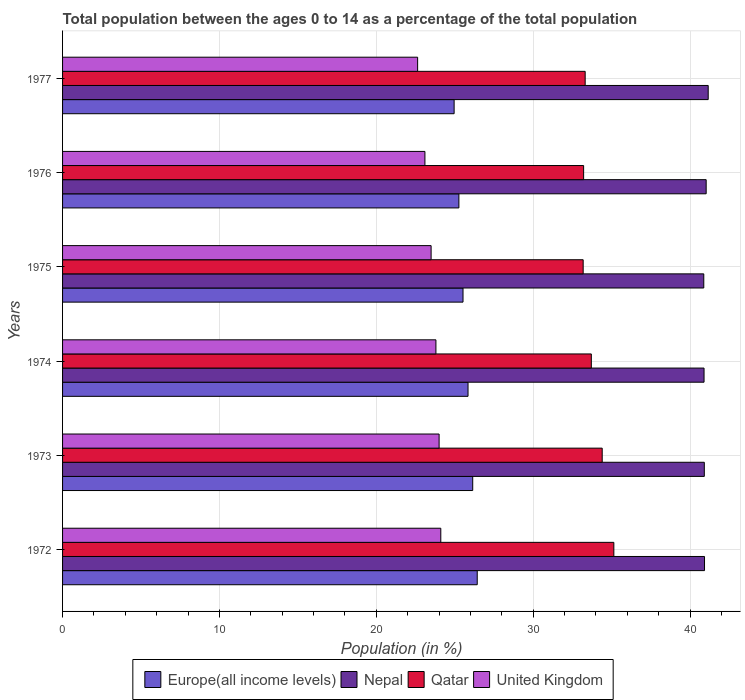How many different coloured bars are there?
Your answer should be very brief. 4. Are the number of bars per tick equal to the number of legend labels?
Your answer should be very brief. Yes. What is the label of the 4th group of bars from the top?
Your response must be concise. 1974. In how many cases, is the number of bars for a given year not equal to the number of legend labels?
Your response must be concise. 0. What is the percentage of the population ages 0 to 14 in Nepal in 1972?
Your answer should be very brief. 40.92. Across all years, what is the maximum percentage of the population ages 0 to 14 in Qatar?
Your response must be concise. 35.14. Across all years, what is the minimum percentage of the population ages 0 to 14 in Qatar?
Provide a succinct answer. 33.18. In which year was the percentage of the population ages 0 to 14 in Qatar maximum?
Your response must be concise. 1972. In which year was the percentage of the population ages 0 to 14 in Nepal minimum?
Provide a short and direct response. 1975. What is the total percentage of the population ages 0 to 14 in Europe(all income levels) in the graph?
Give a very brief answer. 154.17. What is the difference between the percentage of the population ages 0 to 14 in Nepal in 1975 and that in 1977?
Your response must be concise. -0.28. What is the difference between the percentage of the population ages 0 to 14 in Qatar in 1977 and the percentage of the population ages 0 to 14 in Nepal in 1973?
Your answer should be very brief. -7.59. What is the average percentage of the population ages 0 to 14 in Europe(all income levels) per year?
Your answer should be very brief. 25.69. In the year 1974, what is the difference between the percentage of the population ages 0 to 14 in Qatar and percentage of the population ages 0 to 14 in United Kingdom?
Your answer should be very brief. 9.91. What is the ratio of the percentage of the population ages 0 to 14 in Qatar in 1972 to that in 1975?
Give a very brief answer. 1.06. What is the difference between the highest and the second highest percentage of the population ages 0 to 14 in Nepal?
Your answer should be compact. 0.13. What is the difference between the highest and the lowest percentage of the population ages 0 to 14 in Qatar?
Ensure brevity in your answer.  1.96. Is it the case that in every year, the sum of the percentage of the population ages 0 to 14 in Qatar and percentage of the population ages 0 to 14 in Europe(all income levels) is greater than the sum of percentage of the population ages 0 to 14 in United Kingdom and percentage of the population ages 0 to 14 in Nepal?
Offer a terse response. Yes. What does the 1st bar from the top in 1973 represents?
Provide a short and direct response. United Kingdom. What does the 4th bar from the bottom in 1977 represents?
Offer a very short reply. United Kingdom. Is it the case that in every year, the sum of the percentage of the population ages 0 to 14 in Europe(all income levels) and percentage of the population ages 0 to 14 in United Kingdom is greater than the percentage of the population ages 0 to 14 in Qatar?
Make the answer very short. Yes. How many years are there in the graph?
Your answer should be very brief. 6. What is the difference between two consecutive major ticks on the X-axis?
Make the answer very short. 10. Does the graph contain any zero values?
Ensure brevity in your answer.  No. Does the graph contain grids?
Keep it short and to the point. Yes. Where does the legend appear in the graph?
Your response must be concise. Bottom center. How many legend labels are there?
Provide a succinct answer. 4. What is the title of the graph?
Offer a very short reply. Total population between the ages 0 to 14 as a percentage of the total population. Does "St. Lucia" appear as one of the legend labels in the graph?
Offer a terse response. No. What is the label or title of the X-axis?
Offer a very short reply. Population (in %). What is the Population (in %) of Europe(all income levels) in 1972?
Your response must be concise. 26.43. What is the Population (in %) of Nepal in 1972?
Offer a terse response. 40.92. What is the Population (in %) of Qatar in 1972?
Your answer should be compact. 35.14. What is the Population (in %) in United Kingdom in 1972?
Your answer should be compact. 24.11. What is the Population (in %) in Europe(all income levels) in 1973?
Offer a terse response. 26.14. What is the Population (in %) in Nepal in 1973?
Make the answer very short. 40.91. What is the Population (in %) of Qatar in 1973?
Your answer should be compact. 34.4. What is the Population (in %) in United Kingdom in 1973?
Your answer should be compact. 24. What is the Population (in %) in Europe(all income levels) in 1974?
Your answer should be compact. 25.84. What is the Population (in %) in Nepal in 1974?
Offer a very short reply. 40.89. What is the Population (in %) in Qatar in 1974?
Keep it short and to the point. 33.7. What is the Population (in %) in United Kingdom in 1974?
Provide a succinct answer. 23.8. What is the Population (in %) in Europe(all income levels) in 1975?
Give a very brief answer. 25.53. What is the Population (in %) in Nepal in 1975?
Provide a short and direct response. 40.87. What is the Population (in %) in Qatar in 1975?
Offer a terse response. 33.18. What is the Population (in %) of United Kingdom in 1975?
Your answer should be compact. 23.49. What is the Population (in %) of Europe(all income levels) in 1976?
Provide a succinct answer. 25.26. What is the Population (in %) in Nepal in 1976?
Offer a very short reply. 41.02. What is the Population (in %) in Qatar in 1976?
Offer a very short reply. 33.21. What is the Population (in %) in United Kingdom in 1976?
Keep it short and to the point. 23.1. What is the Population (in %) in Europe(all income levels) in 1977?
Provide a succinct answer. 24.96. What is the Population (in %) in Nepal in 1977?
Your response must be concise. 41.15. What is the Population (in %) in Qatar in 1977?
Offer a very short reply. 33.31. What is the Population (in %) in United Kingdom in 1977?
Make the answer very short. 22.63. Across all years, what is the maximum Population (in %) of Europe(all income levels)?
Your answer should be compact. 26.43. Across all years, what is the maximum Population (in %) in Nepal?
Keep it short and to the point. 41.15. Across all years, what is the maximum Population (in %) in Qatar?
Your answer should be very brief. 35.14. Across all years, what is the maximum Population (in %) of United Kingdom?
Offer a very short reply. 24.11. Across all years, what is the minimum Population (in %) of Europe(all income levels)?
Keep it short and to the point. 24.96. Across all years, what is the minimum Population (in %) in Nepal?
Your response must be concise. 40.87. Across all years, what is the minimum Population (in %) of Qatar?
Your answer should be compact. 33.18. Across all years, what is the minimum Population (in %) of United Kingdom?
Offer a terse response. 22.63. What is the total Population (in %) in Europe(all income levels) in the graph?
Offer a terse response. 154.17. What is the total Population (in %) in Nepal in the graph?
Your answer should be very brief. 245.76. What is the total Population (in %) of Qatar in the graph?
Your response must be concise. 202.95. What is the total Population (in %) of United Kingdom in the graph?
Your answer should be very brief. 141.13. What is the difference between the Population (in %) in Europe(all income levels) in 1972 and that in 1973?
Keep it short and to the point. 0.29. What is the difference between the Population (in %) in Nepal in 1972 and that in 1973?
Provide a short and direct response. 0.01. What is the difference between the Population (in %) of Qatar in 1972 and that in 1973?
Make the answer very short. 0.74. What is the difference between the Population (in %) in United Kingdom in 1972 and that in 1973?
Make the answer very short. 0.11. What is the difference between the Population (in %) in Europe(all income levels) in 1972 and that in 1974?
Your answer should be very brief. 0.59. What is the difference between the Population (in %) in Nepal in 1972 and that in 1974?
Offer a very short reply. 0.03. What is the difference between the Population (in %) in Qatar in 1972 and that in 1974?
Keep it short and to the point. 1.44. What is the difference between the Population (in %) in United Kingdom in 1972 and that in 1974?
Your response must be concise. 0.31. What is the difference between the Population (in %) in Europe(all income levels) in 1972 and that in 1975?
Your answer should be compact. 0.91. What is the difference between the Population (in %) of Nepal in 1972 and that in 1975?
Offer a terse response. 0.05. What is the difference between the Population (in %) in Qatar in 1972 and that in 1975?
Your response must be concise. 1.96. What is the difference between the Population (in %) of United Kingdom in 1972 and that in 1975?
Keep it short and to the point. 0.62. What is the difference between the Population (in %) of Europe(all income levels) in 1972 and that in 1976?
Give a very brief answer. 1.17. What is the difference between the Population (in %) of Nepal in 1972 and that in 1976?
Your answer should be very brief. -0.1. What is the difference between the Population (in %) in Qatar in 1972 and that in 1976?
Your response must be concise. 1.93. What is the difference between the Population (in %) in United Kingdom in 1972 and that in 1976?
Provide a succinct answer. 1.01. What is the difference between the Population (in %) of Europe(all income levels) in 1972 and that in 1977?
Your answer should be compact. 1.47. What is the difference between the Population (in %) in Nepal in 1972 and that in 1977?
Ensure brevity in your answer.  -0.24. What is the difference between the Population (in %) in Qatar in 1972 and that in 1977?
Make the answer very short. 1.83. What is the difference between the Population (in %) in United Kingdom in 1972 and that in 1977?
Ensure brevity in your answer.  1.48. What is the difference between the Population (in %) in Europe(all income levels) in 1973 and that in 1974?
Offer a very short reply. 0.3. What is the difference between the Population (in %) of Nepal in 1973 and that in 1974?
Give a very brief answer. 0.02. What is the difference between the Population (in %) in Qatar in 1973 and that in 1974?
Your answer should be compact. 0.69. What is the difference between the Population (in %) of United Kingdom in 1973 and that in 1974?
Offer a terse response. 0.2. What is the difference between the Population (in %) in Europe(all income levels) in 1973 and that in 1975?
Provide a short and direct response. 0.62. What is the difference between the Population (in %) in Nepal in 1973 and that in 1975?
Make the answer very short. 0.03. What is the difference between the Population (in %) in Qatar in 1973 and that in 1975?
Your response must be concise. 1.21. What is the difference between the Population (in %) in United Kingdom in 1973 and that in 1975?
Your response must be concise. 0.51. What is the difference between the Population (in %) of Europe(all income levels) in 1973 and that in 1976?
Give a very brief answer. 0.88. What is the difference between the Population (in %) in Nepal in 1973 and that in 1976?
Keep it short and to the point. -0.12. What is the difference between the Population (in %) of Qatar in 1973 and that in 1976?
Your answer should be compact. 1.18. What is the difference between the Population (in %) in United Kingdom in 1973 and that in 1976?
Your answer should be compact. 0.9. What is the difference between the Population (in %) in Europe(all income levels) in 1973 and that in 1977?
Provide a succinct answer. 1.19. What is the difference between the Population (in %) in Nepal in 1973 and that in 1977?
Offer a terse response. -0.25. What is the difference between the Population (in %) of Qatar in 1973 and that in 1977?
Your answer should be very brief. 1.09. What is the difference between the Population (in %) of United Kingdom in 1973 and that in 1977?
Your answer should be compact. 1.37. What is the difference between the Population (in %) in Europe(all income levels) in 1974 and that in 1975?
Your answer should be very brief. 0.32. What is the difference between the Population (in %) of Nepal in 1974 and that in 1975?
Offer a terse response. 0.02. What is the difference between the Population (in %) of Qatar in 1974 and that in 1975?
Give a very brief answer. 0.52. What is the difference between the Population (in %) of United Kingdom in 1974 and that in 1975?
Keep it short and to the point. 0.31. What is the difference between the Population (in %) of Europe(all income levels) in 1974 and that in 1976?
Provide a short and direct response. 0.58. What is the difference between the Population (in %) of Nepal in 1974 and that in 1976?
Your answer should be very brief. -0.13. What is the difference between the Population (in %) of Qatar in 1974 and that in 1976?
Give a very brief answer. 0.49. What is the difference between the Population (in %) of United Kingdom in 1974 and that in 1976?
Provide a succinct answer. 0.7. What is the difference between the Population (in %) of Europe(all income levels) in 1974 and that in 1977?
Offer a terse response. 0.89. What is the difference between the Population (in %) in Nepal in 1974 and that in 1977?
Offer a very short reply. -0.27. What is the difference between the Population (in %) in Qatar in 1974 and that in 1977?
Provide a succinct answer. 0.39. What is the difference between the Population (in %) in United Kingdom in 1974 and that in 1977?
Give a very brief answer. 1.17. What is the difference between the Population (in %) of Europe(all income levels) in 1975 and that in 1976?
Your response must be concise. 0.26. What is the difference between the Population (in %) in Nepal in 1975 and that in 1976?
Keep it short and to the point. -0.15. What is the difference between the Population (in %) of Qatar in 1975 and that in 1976?
Your answer should be very brief. -0.03. What is the difference between the Population (in %) of United Kingdom in 1975 and that in 1976?
Provide a short and direct response. 0.39. What is the difference between the Population (in %) in Europe(all income levels) in 1975 and that in 1977?
Your answer should be very brief. 0.57. What is the difference between the Population (in %) of Nepal in 1975 and that in 1977?
Your answer should be very brief. -0.28. What is the difference between the Population (in %) of Qatar in 1975 and that in 1977?
Provide a short and direct response. -0.13. What is the difference between the Population (in %) of United Kingdom in 1975 and that in 1977?
Offer a very short reply. 0.86. What is the difference between the Population (in %) of Europe(all income levels) in 1976 and that in 1977?
Make the answer very short. 0.3. What is the difference between the Population (in %) of Nepal in 1976 and that in 1977?
Provide a short and direct response. -0.13. What is the difference between the Population (in %) of Qatar in 1976 and that in 1977?
Your answer should be compact. -0.1. What is the difference between the Population (in %) in United Kingdom in 1976 and that in 1977?
Make the answer very short. 0.47. What is the difference between the Population (in %) of Europe(all income levels) in 1972 and the Population (in %) of Nepal in 1973?
Your answer should be compact. -14.47. What is the difference between the Population (in %) of Europe(all income levels) in 1972 and the Population (in %) of Qatar in 1973?
Provide a succinct answer. -7.97. What is the difference between the Population (in %) of Europe(all income levels) in 1972 and the Population (in %) of United Kingdom in 1973?
Offer a very short reply. 2.43. What is the difference between the Population (in %) in Nepal in 1972 and the Population (in %) in Qatar in 1973?
Give a very brief answer. 6.52. What is the difference between the Population (in %) in Nepal in 1972 and the Population (in %) in United Kingdom in 1973?
Provide a short and direct response. 16.92. What is the difference between the Population (in %) of Qatar in 1972 and the Population (in %) of United Kingdom in 1973?
Your answer should be very brief. 11.14. What is the difference between the Population (in %) in Europe(all income levels) in 1972 and the Population (in %) in Nepal in 1974?
Keep it short and to the point. -14.46. What is the difference between the Population (in %) of Europe(all income levels) in 1972 and the Population (in %) of Qatar in 1974?
Ensure brevity in your answer.  -7.27. What is the difference between the Population (in %) of Europe(all income levels) in 1972 and the Population (in %) of United Kingdom in 1974?
Offer a very short reply. 2.63. What is the difference between the Population (in %) in Nepal in 1972 and the Population (in %) in Qatar in 1974?
Your response must be concise. 7.21. What is the difference between the Population (in %) of Nepal in 1972 and the Population (in %) of United Kingdom in 1974?
Provide a succinct answer. 17.12. What is the difference between the Population (in %) in Qatar in 1972 and the Population (in %) in United Kingdom in 1974?
Your response must be concise. 11.34. What is the difference between the Population (in %) of Europe(all income levels) in 1972 and the Population (in %) of Nepal in 1975?
Offer a very short reply. -14.44. What is the difference between the Population (in %) of Europe(all income levels) in 1972 and the Population (in %) of Qatar in 1975?
Keep it short and to the point. -6.75. What is the difference between the Population (in %) in Europe(all income levels) in 1972 and the Population (in %) in United Kingdom in 1975?
Offer a very short reply. 2.94. What is the difference between the Population (in %) of Nepal in 1972 and the Population (in %) of Qatar in 1975?
Your answer should be compact. 7.74. What is the difference between the Population (in %) in Nepal in 1972 and the Population (in %) in United Kingdom in 1975?
Ensure brevity in your answer.  17.43. What is the difference between the Population (in %) of Qatar in 1972 and the Population (in %) of United Kingdom in 1975?
Keep it short and to the point. 11.65. What is the difference between the Population (in %) of Europe(all income levels) in 1972 and the Population (in %) of Nepal in 1976?
Give a very brief answer. -14.59. What is the difference between the Population (in %) of Europe(all income levels) in 1972 and the Population (in %) of Qatar in 1976?
Your answer should be compact. -6.78. What is the difference between the Population (in %) of Europe(all income levels) in 1972 and the Population (in %) of United Kingdom in 1976?
Ensure brevity in your answer.  3.33. What is the difference between the Population (in %) of Nepal in 1972 and the Population (in %) of Qatar in 1976?
Provide a short and direct response. 7.71. What is the difference between the Population (in %) in Nepal in 1972 and the Population (in %) in United Kingdom in 1976?
Your response must be concise. 17.82. What is the difference between the Population (in %) of Qatar in 1972 and the Population (in %) of United Kingdom in 1976?
Provide a succinct answer. 12.04. What is the difference between the Population (in %) in Europe(all income levels) in 1972 and the Population (in %) in Nepal in 1977?
Make the answer very short. -14.72. What is the difference between the Population (in %) of Europe(all income levels) in 1972 and the Population (in %) of Qatar in 1977?
Provide a succinct answer. -6.88. What is the difference between the Population (in %) in Europe(all income levels) in 1972 and the Population (in %) in United Kingdom in 1977?
Offer a very short reply. 3.8. What is the difference between the Population (in %) of Nepal in 1972 and the Population (in %) of Qatar in 1977?
Offer a terse response. 7.61. What is the difference between the Population (in %) in Nepal in 1972 and the Population (in %) in United Kingdom in 1977?
Offer a terse response. 18.29. What is the difference between the Population (in %) in Qatar in 1972 and the Population (in %) in United Kingdom in 1977?
Provide a succinct answer. 12.51. What is the difference between the Population (in %) of Europe(all income levels) in 1973 and the Population (in %) of Nepal in 1974?
Provide a succinct answer. -14.75. What is the difference between the Population (in %) in Europe(all income levels) in 1973 and the Population (in %) in Qatar in 1974?
Give a very brief answer. -7.56. What is the difference between the Population (in %) of Europe(all income levels) in 1973 and the Population (in %) of United Kingdom in 1974?
Ensure brevity in your answer.  2.35. What is the difference between the Population (in %) in Nepal in 1973 and the Population (in %) in Qatar in 1974?
Offer a very short reply. 7.2. What is the difference between the Population (in %) of Nepal in 1973 and the Population (in %) of United Kingdom in 1974?
Keep it short and to the point. 17.11. What is the difference between the Population (in %) in Qatar in 1973 and the Population (in %) in United Kingdom in 1974?
Provide a short and direct response. 10.6. What is the difference between the Population (in %) of Europe(all income levels) in 1973 and the Population (in %) of Nepal in 1975?
Keep it short and to the point. -14.73. What is the difference between the Population (in %) in Europe(all income levels) in 1973 and the Population (in %) in Qatar in 1975?
Make the answer very short. -7.04. What is the difference between the Population (in %) of Europe(all income levels) in 1973 and the Population (in %) of United Kingdom in 1975?
Ensure brevity in your answer.  2.65. What is the difference between the Population (in %) of Nepal in 1973 and the Population (in %) of Qatar in 1975?
Provide a short and direct response. 7.72. What is the difference between the Population (in %) in Nepal in 1973 and the Population (in %) in United Kingdom in 1975?
Provide a short and direct response. 17.41. What is the difference between the Population (in %) in Qatar in 1973 and the Population (in %) in United Kingdom in 1975?
Provide a short and direct response. 10.91. What is the difference between the Population (in %) in Europe(all income levels) in 1973 and the Population (in %) in Nepal in 1976?
Your answer should be compact. -14.88. What is the difference between the Population (in %) of Europe(all income levels) in 1973 and the Population (in %) of Qatar in 1976?
Your answer should be compact. -7.07. What is the difference between the Population (in %) in Europe(all income levels) in 1973 and the Population (in %) in United Kingdom in 1976?
Offer a terse response. 3.05. What is the difference between the Population (in %) in Nepal in 1973 and the Population (in %) in Qatar in 1976?
Keep it short and to the point. 7.69. What is the difference between the Population (in %) in Nepal in 1973 and the Population (in %) in United Kingdom in 1976?
Make the answer very short. 17.81. What is the difference between the Population (in %) in Qatar in 1973 and the Population (in %) in United Kingdom in 1976?
Your answer should be compact. 11.3. What is the difference between the Population (in %) in Europe(all income levels) in 1973 and the Population (in %) in Nepal in 1977?
Your answer should be compact. -15.01. What is the difference between the Population (in %) in Europe(all income levels) in 1973 and the Population (in %) in Qatar in 1977?
Provide a short and direct response. -7.17. What is the difference between the Population (in %) in Europe(all income levels) in 1973 and the Population (in %) in United Kingdom in 1977?
Your response must be concise. 3.51. What is the difference between the Population (in %) of Nepal in 1973 and the Population (in %) of Qatar in 1977?
Make the answer very short. 7.59. What is the difference between the Population (in %) in Nepal in 1973 and the Population (in %) in United Kingdom in 1977?
Your answer should be compact. 18.27. What is the difference between the Population (in %) of Qatar in 1973 and the Population (in %) of United Kingdom in 1977?
Give a very brief answer. 11.77. What is the difference between the Population (in %) of Europe(all income levels) in 1974 and the Population (in %) of Nepal in 1975?
Keep it short and to the point. -15.03. What is the difference between the Population (in %) of Europe(all income levels) in 1974 and the Population (in %) of Qatar in 1975?
Your response must be concise. -7.34. What is the difference between the Population (in %) in Europe(all income levels) in 1974 and the Population (in %) in United Kingdom in 1975?
Your answer should be very brief. 2.35. What is the difference between the Population (in %) in Nepal in 1974 and the Population (in %) in Qatar in 1975?
Provide a short and direct response. 7.71. What is the difference between the Population (in %) of Nepal in 1974 and the Population (in %) of United Kingdom in 1975?
Provide a succinct answer. 17.4. What is the difference between the Population (in %) in Qatar in 1974 and the Population (in %) in United Kingdom in 1975?
Ensure brevity in your answer.  10.21. What is the difference between the Population (in %) of Europe(all income levels) in 1974 and the Population (in %) of Nepal in 1976?
Give a very brief answer. -15.18. What is the difference between the Population (in %) of Europe(all income levels) in 1974 and the Population (in %) of Qatar in 1976?
Keep it short and to the point. -7.37. What is the difference between the Population (in %) in Europe(all income levels) in 1974 and the Population (in %) in United Kingdom in 1976?
Offer a very short reply. 2.75. What is the difference between the Population (in %) of Nepal in 1974 and the Population (in %) of Qatar in 1976?
Provide a succinct answer. 7.68. What is the difference between the Population (in %) in Nepal in 1974 and the Population (in %) in United Kingdom in 1976?
Offer a very short reply. 17.79. What is the difference between the Population (in %) of Qatar in 1974 and the Population (in %) of United Kingdom in 1976?
Provide a short and direct response. 10.61. What is the difference between the Population (in %) of Europe(all income levels) in 1974 and the Population (in %) of Nepal in 1977?
Your response must be concise. -15.31. What is the difference between the Population (in %) of Europe(all income levels) in 1974 and the Population (in %) of Qatar in 1977?
Your answer should be compact. -7.47. What is the difference between the Population (in %) of Europe(all income levels) in 1974 and the Population (in %) of United Kingdom in 1977?
Provide a succinct answer. 3.21. What is the difference between the Population (in %) of Nepal in 1974 and the Population (in %) of Qatar in 1977?
Provide a short and direct response. 7.58. What is the difference between the Population (in %) of Nepal in 1974 and the Population (in %) of United Kingdom in 1977?
Give a very brief answer. 18.26. What is the difference between the Population (in %) of Qatar in 1974 and the Population (in %) of United Kingdom in 1977?
Provide a succinct answer. 11.07. What is the difference between the Population (in %) in Europe(all income levels) in 1975 and the Population (in %) in Nepal in 1976?
Give a very brief answer. -15.5. What is the difference between the Population (in %) of Europe(all income levels) in 1975 and the Population (in %) of Qatar in 1976?
Provide a succinct answer. -7.69. What is the difference between the Population (in %) in Europe(all income levels) in 1975 and the Population (in %) in United Kingdom in 1976?
Give a very brief answer. 2.43. What is the difference between the Population (in %) in Nepal in 1975 and the Population (in %) in Qatar in 1976?
Ensure brevity in your answer.  7.66. What is the difference between the Population (in %) of Nepal in 1975 and the Population (in %) of United Kingdom in 1976?
Provide a succinct answer. 17.77. What is the difference between the Population (in %) of Qatar in 1975 and the Population (in %) of United Kingdom in 1976?
Provide a short and direct response. 10.09. What is the difference between the Population (in %) of Europe(all income levels) in 1975 and the Population (in %) of Nepal in 1977?
Offer a terse response. -15.63. What is the difference between the Population (in %) in Europe(all income levels) in 1975 and the Population (in %) in Qatar in 1977?
Offer a very short reply. -7.79. What is the difference between the Population (in %) of Europe(all income levels) in 1975 and the Population (in %) of United Kingdom in 1977?
Provide a succinct answer. 2.89. What is the difference between the Population (in %) of Nepal in 1975 and the Population (in %) of Qatar in 1977?
Your answer should be very brief. 7.56. What is the difference between the Population (in %) of Nepal in 1975 and the Population (in %) of United Kingdom in 1977?
Offer a terse response. 18.24. What is the difference between the Population (in %) in Qatar in 1975 and the Population (in %) in United Kingdom in 1977?
Your answer should be very brief. 10.55. What is the difference between the Population (in %) in Europe(all income levels) in 1976 and the Population (in %) in Nepal in 1977?
Give a very brief answer. -15.89. What is the difference between the Population (in %) in Europe(all income levels) in 1976 and the Population (in %) in Qatar in 1977?
Your answer should be very brief. -8.05. What is the difference between the Population (in %) of Europe(all income levels) in 1976 and the Population (in %) of United Kingdom in 1977?
Your answer should be compact. 2.63. What is the difference between the Population (in %) in Nepal in 1976 and the Population (in %) in Qatar in 1977?
Provide a succinct answer. 7.71. What is the difference between the Population (in %) of Nepal in 1976 and the Population (in %) of United Kingdom in 1977?
Provide a short and direct response. 18.39. What is the difference between the Population (in %) in Qatar in 1976 and the Population (in %) in United Kingdom in 1977?
Provide a short and direct response. 10.58. What is the average Population (in %) in Europe(all income levels) per year?
Ensure brevity in your answer.  25.69. What is the average Population (in %) of Nepal per year?
Your response must be concise. 40.96. What is the average Population (in %) in Qatar per year?
Provide a short and direct response. 33.83. What is the average Population (in %) of United Kingdom per year?
Make the answer very short. 23.52. In the year 1972, what is the difference between the Population (in %) in Europe(all income levels) and Population (in %) in Nepal?
Provide a succinct answer. -14.49. In the year 1972, what is the difference between the Population (in %) in Europe(all income levels) and Population (in %) in Qatar?
Your answer should be compact. -8.71. In the year 1972, what is the difference between the Population (in %) in Europe(all income levels) and Population (in %) in United Kingdom?
Provide a succinct answer. 2.32. In the year 1972, what is the difference between the Population (in %) of Nepal and Population (in %) of Qatar?
Provide a short and direct response. 5.78. In the year 1972, what is the difference between the Population (in %) in Nepal and Population (in %) in United Kingdom?
Ensure brevity in your answer.  16.81. In the year 1972, what is the difference between the Population (in %) of Qatar and Population (in %) of United Kingdom?
Your answer should be very brief. 11.03. In the year 1973, what is the difference between the Population (in %) in Europe(all income levels) and Population (in %) in Nepal?
Your answer should be compact. -14.76. In the year 1973, what is the difference between the Population (in %) in Europe(all income levels) and Population (in %) in Qatar?
Keep it short and to the point. -8.25. In the year 1973, what is the difference between the Population (in %) of Europe(all income levels) and Population (in %) of United Kingdom?
Provide a succinct answer. 2.14. In the year 1973, what is the difference between the Population (in %) in Nepal and Population (in %) in Qatar?
Keep it short and to the point. 6.51. In the year 1973, what is the difference between the Population (in %) in Nepal and Population (in %) in United Kingdom?
Provide a succinct answer. 16.9. In the year 1973, what is the difference between the Population (in %) in Qatar and Population (in %) in United Kingdom?
Offer a very short reply. 10.4. In the year 1974, what is the difference between the Population (in %) of Europe(all income levels) and Population (in %) of Nepal?
Give a very brief answer. -15.04. In the year 1974, what is the difference between the Population (in %) of Europe(all income levels) and Population (in %) of Qatar?
Keep it short and to the point. -7.86. In the year 1974, what is the difference between the Population (in %) in Europe(all income levels) and Population (in %) in United Kingdom?
Provide a succinct answer. 2.05. In the year 1974, what is the difference between the Population (in %) of Nepal and Population (in %) of Qatar?
Your response must be concise. 7.18. In the year 1974, what is the difference between the Population (in %) of Nepal and Population (in %) of United Kingdom?
Your answer should be very brief. 17.09. In the year 1974, what is the difference between the Population (in %) of Qatar and Population (in %) of United Kingdom?
Your answer should be very brief. 9.91. In the year 1975, what is the difference between the Population (in %) in Europe(all income levels) and Population (in %) in Nepal?
Your answer should be compact. -15.35. In the year 1975, what is the difference between the Population (in %) in Europe(all income levels) and Population (in %) in Qatar?
Provide a short and direct response. -7.66. In the year 1975, what is the difference between the Population (in %) in Europe(all income levels) and Population (in %) in United Kingdom?
Keep it short and to the point. 2.03. In the year 1975, what is the difference between the Population (in %) of Nepal and Population (in %) of Qatar?
Ensure brevity in your answer.  7.69. In the year 1975, what is the difference between the Population (in %) in Nepal and Population (in %) in United Kingdom?
Give a very brief answer. 17.38. In the year 1975, what is the difference between the Population (in %) in Qatar and Population (in %) in United Kingdom?
Give a very brief answer. 9.69. In the year 1976, what is the difference between the Population (in %) of Europe(all income levels) and Population (in %) of Nepal?
Provide a short and direct response. -15.76. In the year 1976, what is the difference between the Population (in %) of Europe(all income levels) and Population (in %) of Qatar?
Provide a succinct answer. -7.95. In the year 1976, what is the difference between the Population (in %) in Europe(all income levels) and Population (in %) in United Kingdom?
Your answer should be very brief. 2.17. In the year 1976, what is the difference between the Population (in %) in Nepal and Population (in %) in Qatar?
Make the answer very short. 7.81. In the year 1976, what is the difference between the Population (in %) in Nepal and Population (in %) in United Kingdom?
Give a very brief answer. 17.93. In the year 1976, what is the difference between the Population (in %) of Qatar and Population (in %) of United Kingdom?
Offer a terse response. 10.12. In the year 1977, what is the difference between the Population (in %) in Europe(all income levels) and Population (in %) in Nepal?
Your answer should be compact. -16.2. In the year 1977, what is the difference between the Population (in %) in Europe(all income levels) and Population (in %) in Qatar?
Your response must be concise. -8.35. In the year 1977, what is the difference between the Population (in %) of Europe(all income levels) and Population (in %) of United Kingdom?
Your answer should be compact. 2.33. In the year 1977, what is the difference between the Population (in %) in Nepal and Population (in %) in Qatar?
Keep it short and to the point. 7.84. In the year 1977, what is the difference between the Population (in %) of Nepal and Population (in %) of United Kingdom?
Provide a short and direct response. 18.52. In the year 1977, what is the difference between the Population (in %) of Qatar and Population (in %) of United Kingdom?
Offer a very short reply. 10.68. What is the ratio of the Population (in %) in Nepal in 1972 to that in 1973?
Offer a terse response. 1. What is the ratio of the Population (in %) of Qatar in 1972 to that in 1973?
Provide a short and direct response. 1.02. What is the ratio of the Population (in %) of Europe(all income levels) in 1972 to that in 1974?
Provide a succinct answer. 1.02. What is the ratio of the Population (in %) of Qatar in 1972 to that in 1974?
Give a very brief answer. 1.04. What is the ratio of the Population (in %) in United Kingdom in 1972 to that in 1974?
Ensure brevity in your answer.  1.01. What is the ratio of the Population (in %) of Europe(all income levels) in 1972 to that in 1975?
Offer a very short reply. 1.04. What is the ratio of the Population (in %) of Qatar in 1972 to that in 1975?
Ensure brevity in your answer.  1.06. What is the ratio of the Population (in %) in United Kingdom in 1972 to that in 1975?
Provide a succinct answer. 1.03. What is the ratio of the Population (in %) in Europe(all income levels) in 1972 to that in 1976?
Make the answer very short. 1.05. What is the ratio of the Population (in %) in Qatar in 1972 to that in 1976?
Your answer should be very brief. 1.06. What is the ratio of the Population (in %) in United Kingdom in 1972 to that in 1976?
Your answer should be compact. 1.04. What is the ratio of the Population (in %) of Europe(all income levels) in 1972 to that in 1977?
Give a very brief answer. 1.06. What is the ratio of the Population (in %) in Qatar in 1972 to that in 1977?
Make the answer very short. 1.05. What is the ratio of the Population (in %) in United Kingdom in 1972 to that in 1977?
Give a very brief answer. 1.07. What is the ratio of the Population (in %) of Europe(all income levels) in 1973 to that in 1974?
Your answer should be very brief. 1.01. What is the ratio of the Population (in %) of Qatar in 1973 to that in 1974?
Offer a very short reply. 1.02. What is the ratio of the Population (in %) in United Kingdom in 1973 to that in 1974?
Make the answer very short. 1.01. What is the ratio of the Population (in %) in Europe(all income levels) in 1973 to that in 1975?
Offer a terse response. 1.02. What is the ratio of the Population (in %) in Qatar in 1973 to that in 1975?
Offer a terse response. 1.04. What is the ratio of the Population (in %) in United Kingdom in 1973 to that in 1975?
Give a very brief answer. 1.02. What is the ratio of the Population (in %) in Europe(all income levels) in 1973 to that in 1976?
Offer a terse response. 1.03. What is the ratio of the Population (in %) of Nepal in 1973 to that in 1976?
Make the answer very short. 1. What is the ratio of the Population (in %) in Qatar in 1973 to that in 1976?
Keep it short and to the point. 1.04. What is the ratio of the Population (in %) in United Kingdom in 1973 to that in 1976?
Your answer should be compact. 1.04. What is the ratio of the Population (in %) of Europe(all income levels) in 1973 to that in 1977?
Your answer should be very brief. 1.05. What is the ratio of the Population (in %) in Nepal in 1973 to that in 1977?
Provide a succinct answer. 0.99. What is the ratio of the Population (in %) in Qatar in 1973 to that in 1977?
Provide a succinct answer. 1.03. What is the ratio of the Population (in %) of United Kingdom in 1973 to that in 1977?
Your answer should be very brief. 1.06. What is the ratio of the Population (in %) in Europe(all income levels) in 1974 to that in 1975?
Ensure brevity in your answer.  1.01. What is the ratio of the Population (in %) in Nepal in 1974 to that in 1975?
Make the answer very short. 1. What is the ratio of the Population (in %) of Qatar in 1974 to that in 1975?
Keep it short and to the point. 1.02. What is the ratio of the Population (in %) of United Kingdom in 1974 to that in 1975?
Provide a succinct answer. 1.01. What is the ratio of the Population (in %) of Europe(all income levels) in 1974 to that in 1976?
Offer a very short reply. 1.02. What is the ratio of the Population (in %) in Qatar in 1974 to that in 1976?
Provide a succinct answer. 1.01. What is the ratio of the Population (in %) of United Kingdom in 1974 to that in 1976?
Keep it short and to the point. 1.03. What is the ratio of the Population (in %) in Europe(all income levels) in 1974 to that in 1977?
Keep it short and to the point. 1.04. What is the ratio of the Population (in %) of Qatar in 1974 to that in 1977?
Provide a succinct answer. 1.01. What is the ratio of the Population (in %) of United Kingdom in 1974 to that in 1977?
Offer a very short reply. 1.05. What is the ratio of the Population (in %) of Europe(all income levels) in 1975 to that in 1976?
Make the answer very short. 1.01. What is the ratio of the Population (in %) in United Kingdom in 1975 to that in 1976?
Give a very brief answer. 1.02. What is the ratio of the Population (in %) in Europe(all income levels) in 1975 to that in 1977?
Keep it short and to the point. 1.02. What is the ratio of the Population (in %) in Nepal in 1975 to that in 1977?
Your answer should be compact. 0.99. What is the ratio of the Population (in %) in Qatar in 1975 to that in 1977?
Provide a succinct answer. 1. What is the ratio of the Population (in %) in United Kingdom in 1975 to that in 1977?
Give a very brief answer. 1.04. What is the ratio of the Population (in %) of Europe(all income levels) in 1976 to that in 1977?
Your answer should be compact. 1.01. What is the ratio of the Population (in %) of Nepal in 1976 to that in 1977?
Make the answer very short. 1. What is the ratio of the Population (in %) in Qatar in 1976 to that in 1977?
Provide a succinct answer. 1. What is the ratio of the Population (in %) of United Kingdom in 1976 to that in 1977?
Ensure brevity in your answer.  1.02. What is the difference between the highest and the second highest Population (in %) of Europe(all income levels)?
Give a very brief answer. 0.29. What is the difference between the highest and the second highest Population (in %) of Nepal?
Keep it short and to the point. 0.13. What is the difference between the highest and the second highest Population (in %) in Qatar?
Offer a very short reply. 0.74. What is the difference between the highest and the second highest Population (in %) of United Kingdom?
Keep it short and to the point. 0.11. What is the difference between the highest and the lowest Population (in %) of Europe(all income levels)?
Offer a very short reply. 1.47. What is the difference between the highest and the lowest Population (in %) of Nepal?
Your answer should be compact. 0.28. What is the difference between the highest and the lowest Population (in %) of Qatar?
Ensure brevity in your answer.  1.96. What is the difference between the highest and the lowest Population (in %) in United Kingdom?
Your answer should be compact. 1.48. 